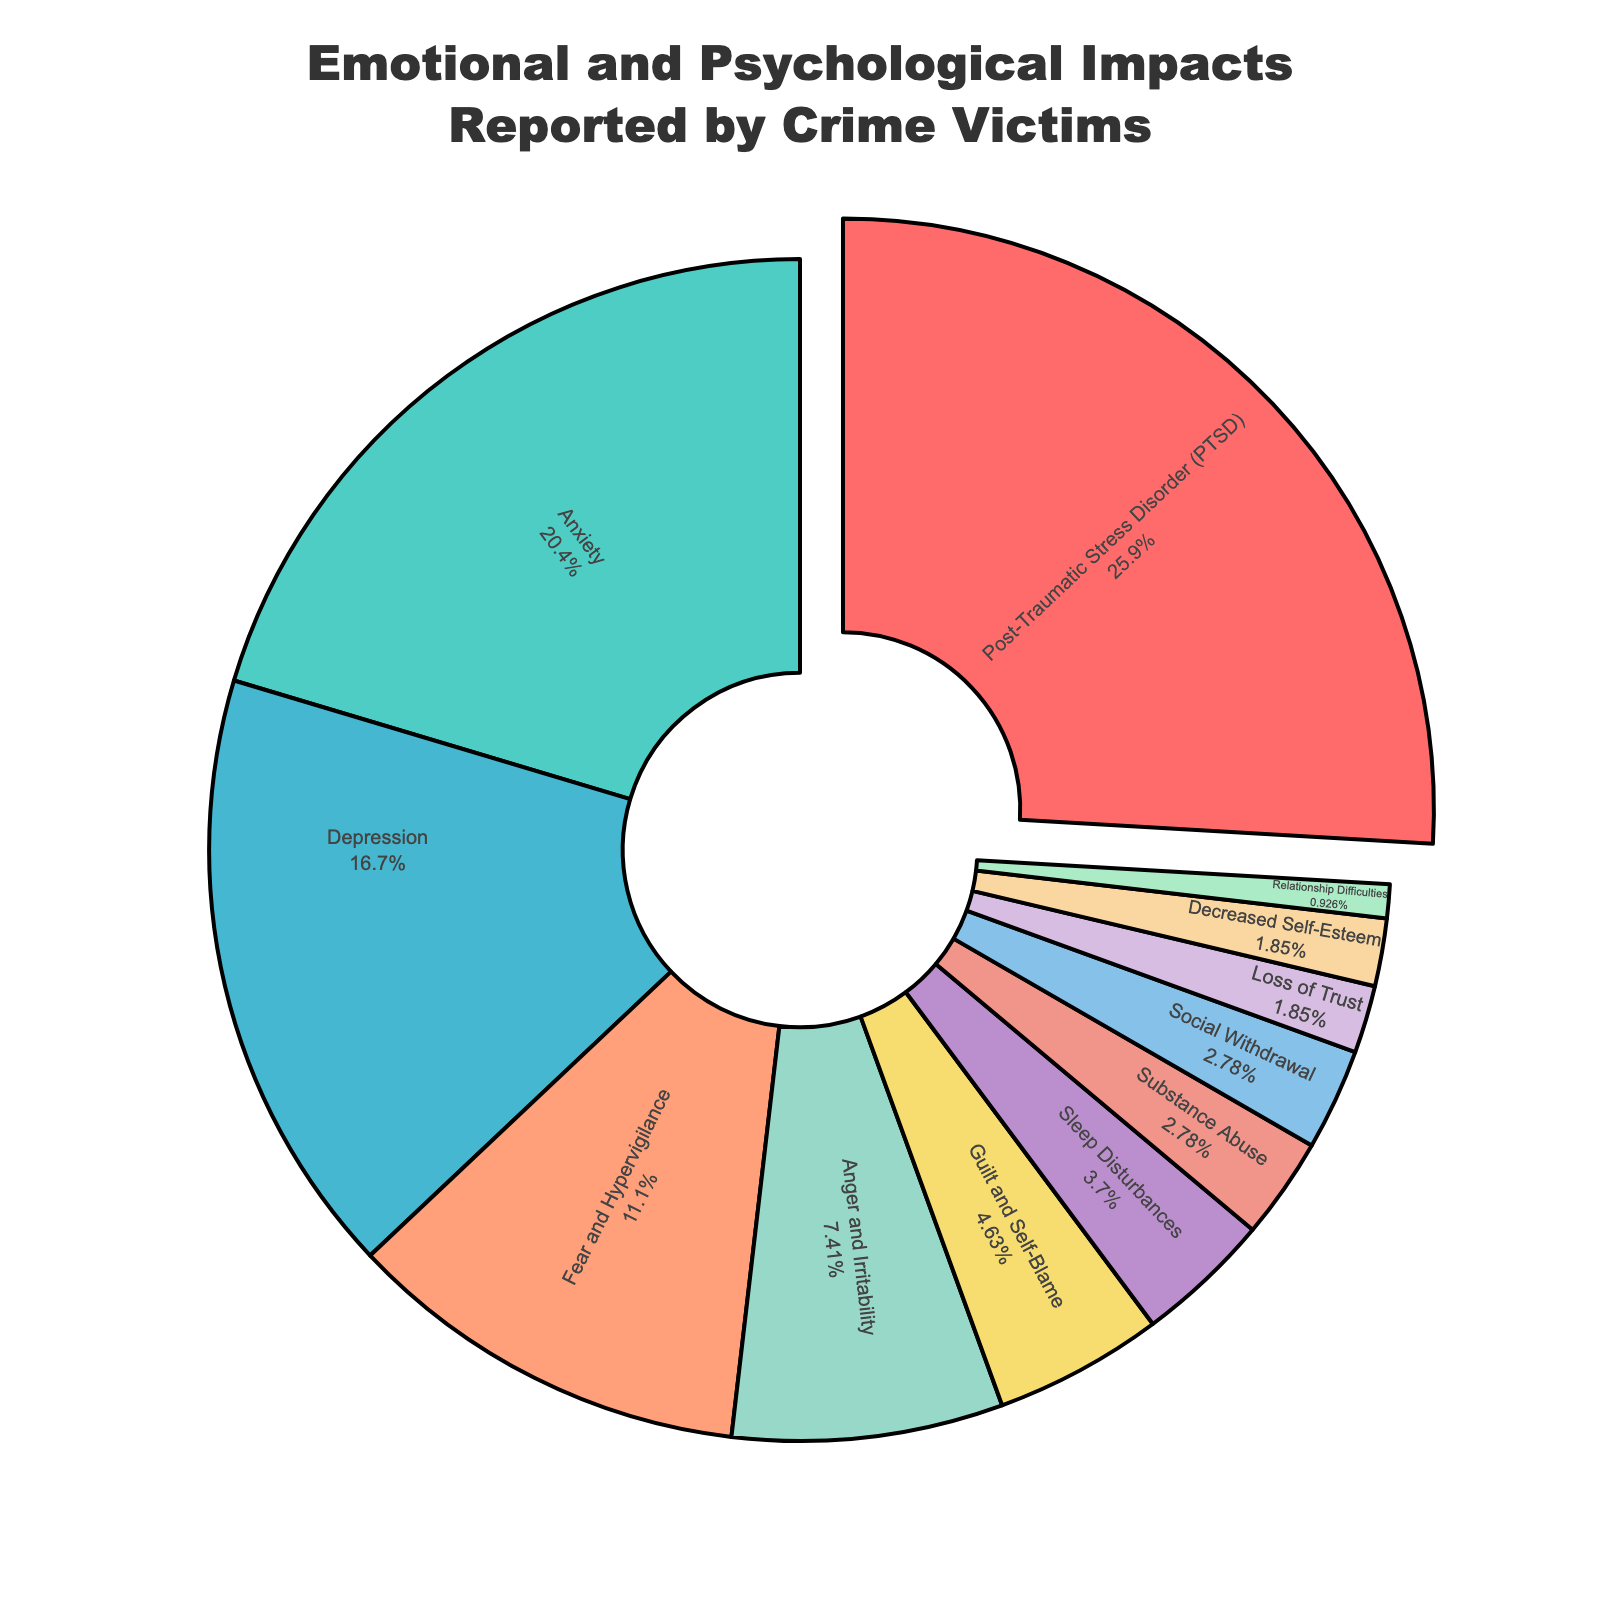How many more victims reported PTSD than reported Depression? First, note the percentages for PTSD (28%) and Depression (18%). Subtract the percentage of Depression from PTSD: 28% - 18% = 10%.
Answer: 10% Which type of impact is reported by the fewest victims? Identify the segment with the smallest percentage. Relationship Difficulties is 1%, which is the smallest.
Answer: Relationship Difficulties What is the combined percentage of victims reporting Anxiety and Fear and Hypervigilance? Identify the percentages for Anxiety (22%) and Fear and Hypervigilance (12%). Add them together: 22% + 12% = 34%.
Answer: 34% Does Anxiety impact more victims than Depression? Compare the values for Anxiety (22%) and Depression (18%). Since 22% > 18%, Anxiety impacts more victims.
Answer: Yes Which impact category is represented by a greenish color in the figure? Match the greenish color to the impact category. The second segment (22%) marked green represents Anxiety.
Answer: Anxiety How many impact types are reported by less than 5% of victims? Identify all impact types below 5%: Guilt and Self-Blame (5%), Sleep Disturbances (4%), Substance Abuse (3%), Social Withdrawal (3%), Loss of Trust (2%), Decreased Self-Esteem (2%), and Relationship Difficulties (1%). Count them: 7 types.
Answer: 7 Which impact categories together equal the sum of Anger and Irritability and Loss of Trust? Calculate Anger and Irritability (8%) + Loss of Trust (2%) = 10%. Categories that sum to 10%: Decreased Self-Esteem (2%) + Relationship Difficulties (1%) + Substance Abuse (3%) + Social Withdrawal (3%) + Sleep Disturbances (4%).
Answer: Decreased Self-Esteem, Relationship Difficulties, Substance Abuse, Social Withdrawal, Sleep Disturbances Do more victims report Guilt and Self-Blame or Relationship Difficulties? Compare the values for Guilt and Self-Blame (5%) and Relationship Difficulties (1%). Since 5% > 1%, Guilt and Self-Blame is reported more.
Answer: Guilt and Self-Blame Which two impacts together make up half of the reported impacts? Identify the top impacts: PTSD (28%) and Anxiety (22%). Add them: 28% + 22% = 50%.
Answer: PTSD and Anxiety What is the percentage difference between the least and most reported impacts? Identify the least (Relationship Difficulties, 1%) and most (PTSD, 28%) reported impacts. Calculate the difference: 28% - 1% = 27%.
Answer: 27% 